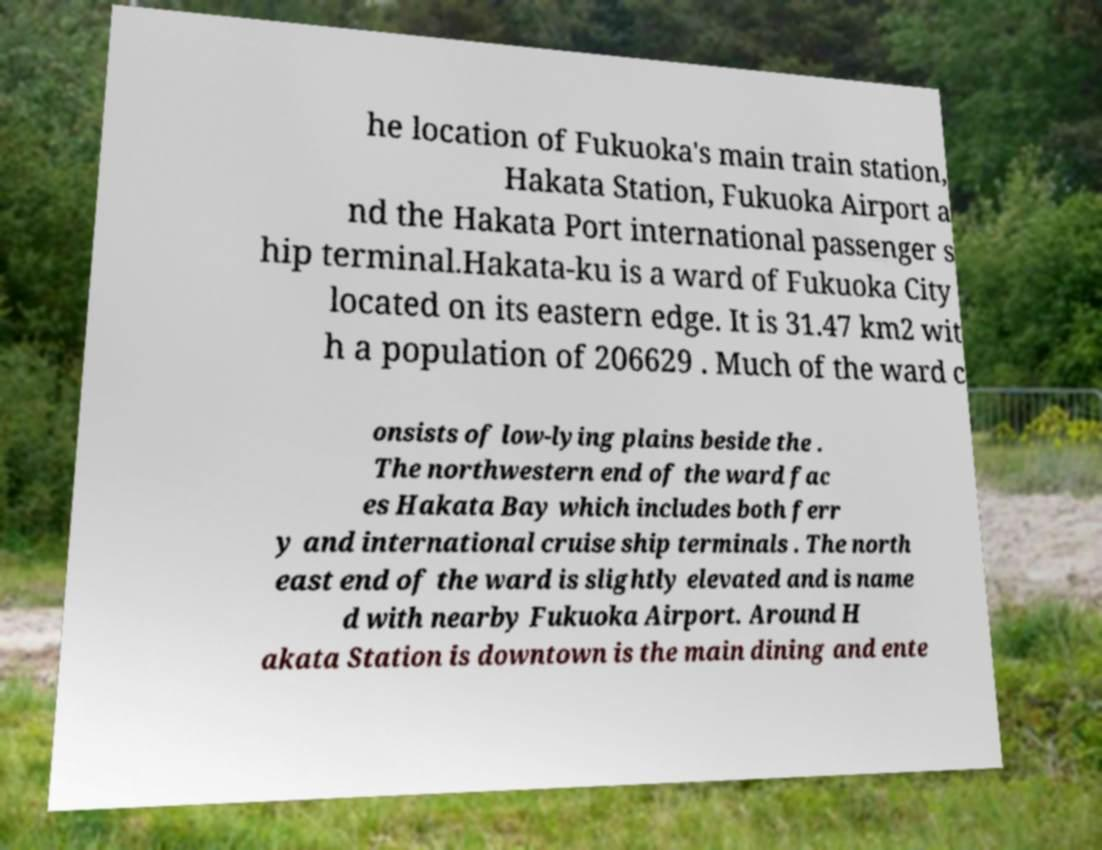I need the written content from this picture converted into text. Can you do that? he location of Fukuoka's main train station, Hakata Station, Fukuoka Airport a nd the Hakata Port international passenger s hip terminal.Hakata-ku is a ward of Fukuoka City located on its eastern edge. It is 31.47 km2 wit h a population of 206629 . Much of the ward c onsists of low-lying plains beside the . The northwestern end of the ward fac es Hakata Bay which includes both ferr y and international cruise ship terminals . The north east end of the ward is slightly elevated and is name d with nearby Fukuoka Airport. Around H akata Station is downtown is the main dining and ente 